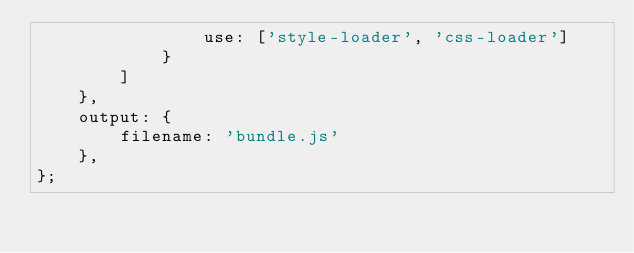Convert code to text. <code><loc_0><loc_0><loc_500><loc_500><_JavaScript_>                use: ['style-loader', 'css-loader']
            }
        ]
    },
    output: {
        filename: 'bundle.js'
    },
};
</code> 